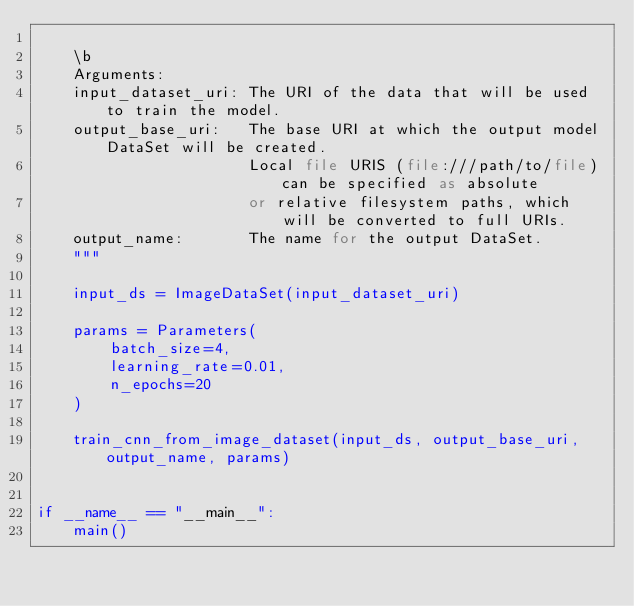Convert code to text. <code><loc_0><loc_0><loc_500><loc_500><_Python_>
    \b
    Arguments:
    input_dataset_uri: The URI of the data that will be used to train the model.
    output_base_uri:   The base URI at which the output model DataSet will be created.
                       Local file URIS (file:///path/to/file) can be specified as absolute
                       or relative filesystem paths, which will be converted to full URIs.
    output_name:       The name for the output DataSet.  
    """

    input_ds = ImageDataSet(input_dataset_uri)

    params = Parameters(
        batch_size=4,
        learning_rate=0.01,
        n_epochs=20
    )

    train_cnn_from_image_dataset(input_ds, output_base_uri, output_name, params)


if __name__ == "__main__":
    main()
</code> 